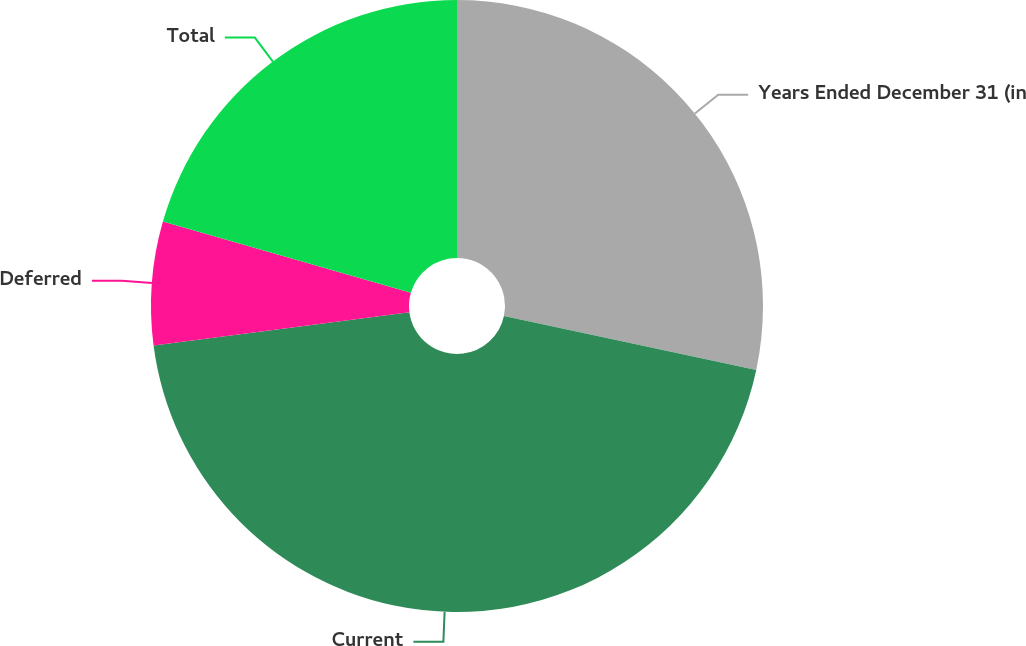Convert chart to OTSL. <chart><loc_0><loc_0><loc_500><loc_500><pie_chart><fcel>Years Ended December 31 (in<fcel>Current<fcel>Deferred<fcel>Total<nl><fcel>28.35%<fcel>44.59%<fcel>6.51%<fcel>20.55%<nl></chart> 